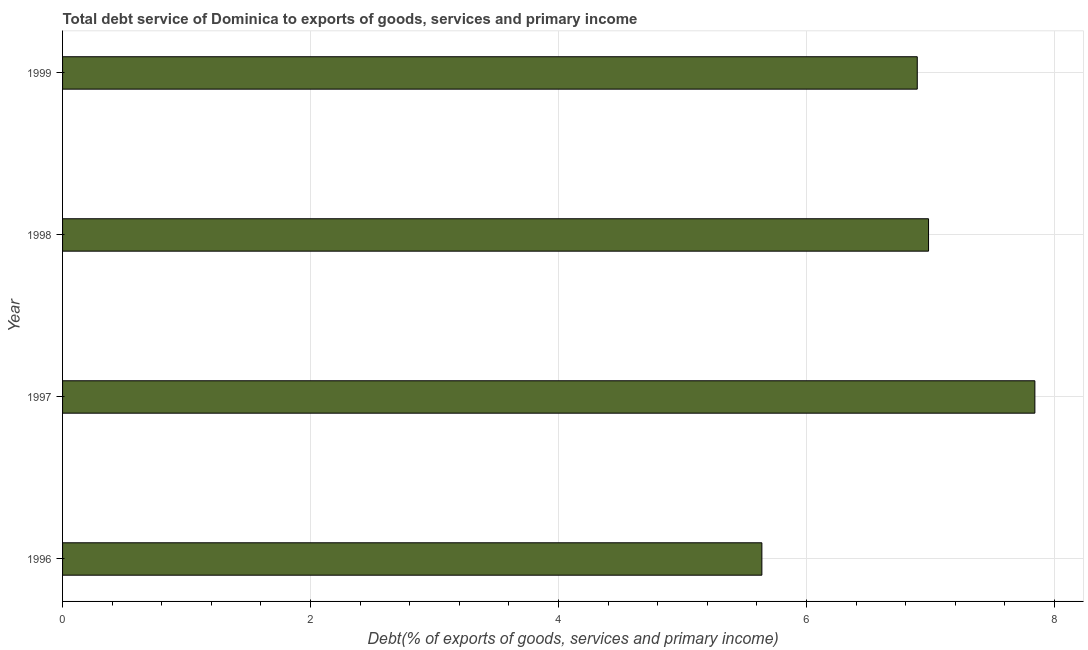What is the title of the graph?
Ensure brevity in your answer.  Total debt service of Dominica to exports of goods, services and primary income. What is the label or title of the X-axis?
Provide a succinct answer. Debt(% of exports of goods, services and primary income). What is the total debt service in 1999?
Your answer should be compact. 6.89. Across all years, what is the maximum total debt service?
Your answer should be very brief. 7.84. Across all years, what is the minimum total debt service?
Provide a succinct answer. 5.64. In which year was the total debt service minimum?
Keep it short and to the point. 1996. What is the sum of the total debt service?
Provide a succinct answer. 27.36. What is the difference between the total debt service in 1997 and 1998?
Your answer should be compact. 0.86. What is the average total debt service per year?
Keep it short and to the point. 6.84. What is the median total debt service?
Your answer should be compact. 6.94. In how many years, is the total debt service greater than 6.8 %?
Your answer should be compact. 3. What is the ratio of the total debt service in 1997 to that in 1998?
Your response must be concise. 1.12. Is the difference between the total debt service in 1997 and 1998 greater than the difference between any two years?
Keep it short and to the point. No. What is the difference between the highest and the second highest total debt service?
Make the answer very short. 0.86. What is the difference between the highest and the lowest total debt service?
Offer a terse response. 2.2. In how many years, is the total debt service greater than the average total debt service taken over all years?
Provide a succinct answer. 3. How many bars are there?
Ensure brevity in your answer.  4. Are all the bars in the graph horizontal?
Provide a succinct answer. Yes. Are the values on the major ticks of X-axis written in scientific E-notation?
Give a very brief answer. No. What is the Debt(% of exports of goods, services and primary income) in 1996?
Provide a short and direct response. 5.64. What is the Debt(% of exports of goods, services and primary income) in 1997?
Ensure brevity in your answer.  7.84. What is the Debt(% of exports of goods, services and primary income) in 1998?
Your answer should be very brief. 6.98. What is the Debt(% of exports of goods, services and primary income) of 1999?
Provide a succinct answer. 6.89. What is the difference between the Debt(% of exports of goods, services and primary income) in 1996 and 1997?
Ensure brevity in your answer.  -2.2. What is the difference between the Debt(% of exports of goods, services and primary income) in 1996 and 1998?
Offer a very short reply. -1.34. What is the difference between the Debt(% of exports of goods, services and primary income) in 1996 and 1999?
Offer a terse response. -1.25. What is the difference between the Debt(% of exports of goods, services and primary income) in 1997 and 1998?
Your answer should be very brief. 0.86. What is the difference between the Debt(% of exports of goods, services and primary income) in 1997 and 1999?
Give a very brief answer. 0.95. What is the difference between the Debt(% of exports of goods, services and primary income) in 1998 and 1999?
Offer a very short reply. 0.09. What is the ratio of the Debt(% of exports of goods, services and primary income) in 1996 to that in 1997?
Your answer should be compact. 0.72. What is the ratio of the Debt(% of exports of goods, services and primary income) in 1996 to that in 1998?
Make the answer very short. 0.81. What is the ratio of the Debt(% of exports of goods, services and primary income) in 1996 to that in 1999?
Your answer should be compact. 0.82. What is the ratio of the Debt(% of exports of goods, services and primary income) in 1997 to that in 1998?
Offer a terse response. 1.12. What is the ratio of the Debt(% of exports of goods, services and primary income) in 1997 to that in 1999?
Your answer should be compact. 1.14. What is the ratio of the Debt(% of exports of goods, services and primary income) in 1998 to that in 1999?
Keep it short and to the point. 1.01. 